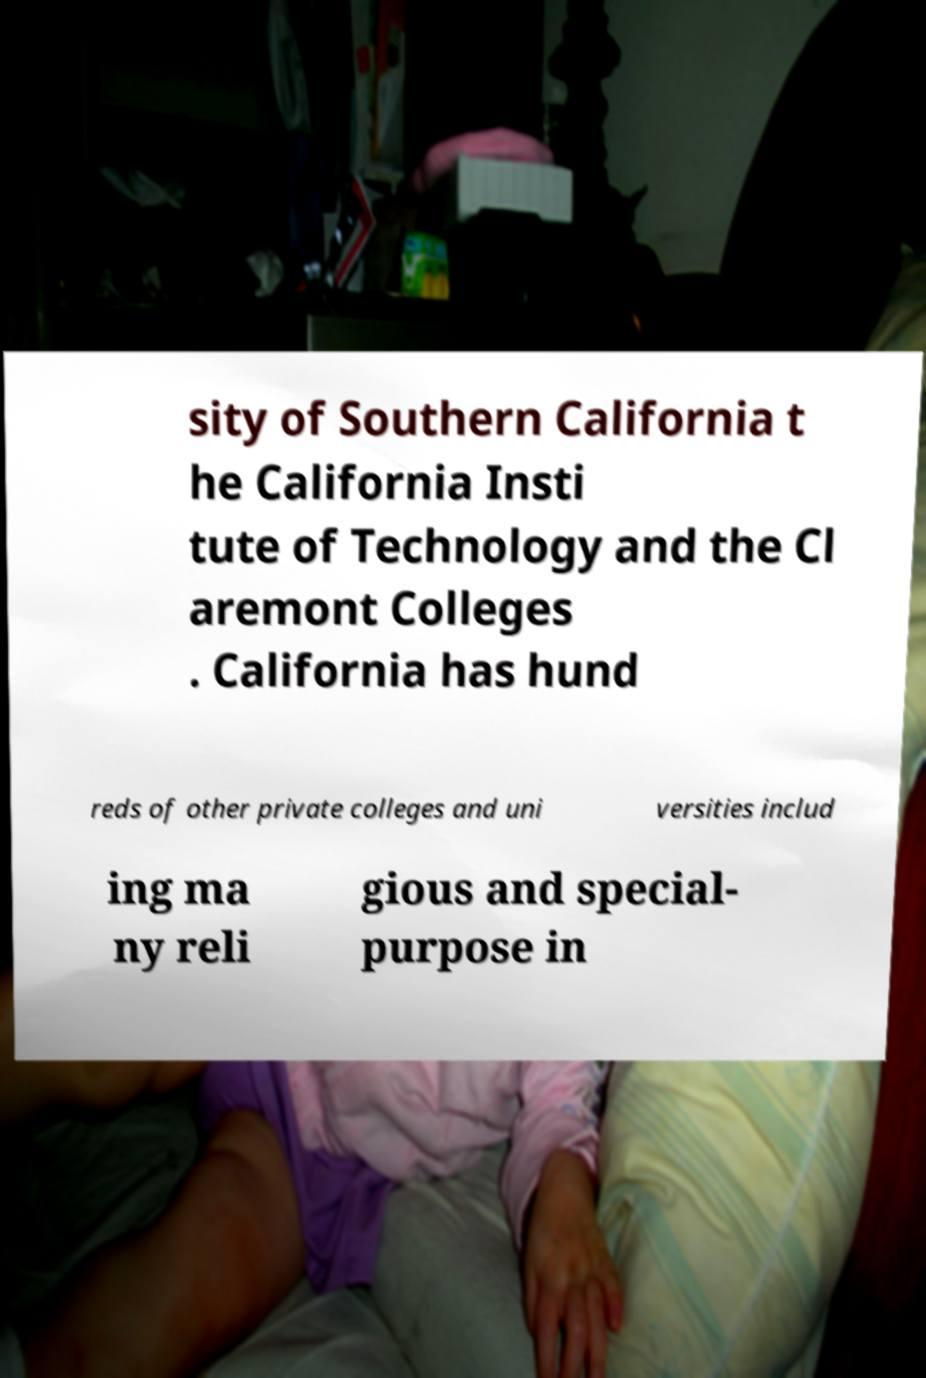Could you assist in decoding the text presented in this image and type it out clearly? sity of Southern California t he California Insti tute of Technology and the Cl aremont Colleges . California has hund reds of other private colleges and uni versities includ ing ma ny reli gious and special- purpose in 